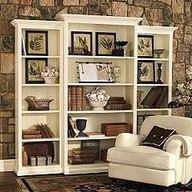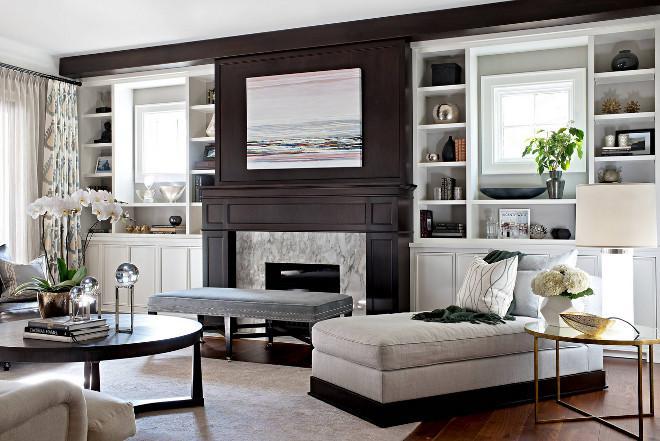The first image is the image on the left, the second image is the image on the right. Analyze the images presented: Is the assertion "One image shows a room with peaked, beamed ceiling above bookshelves and other furniture." valid? Answer yes or no. No. 